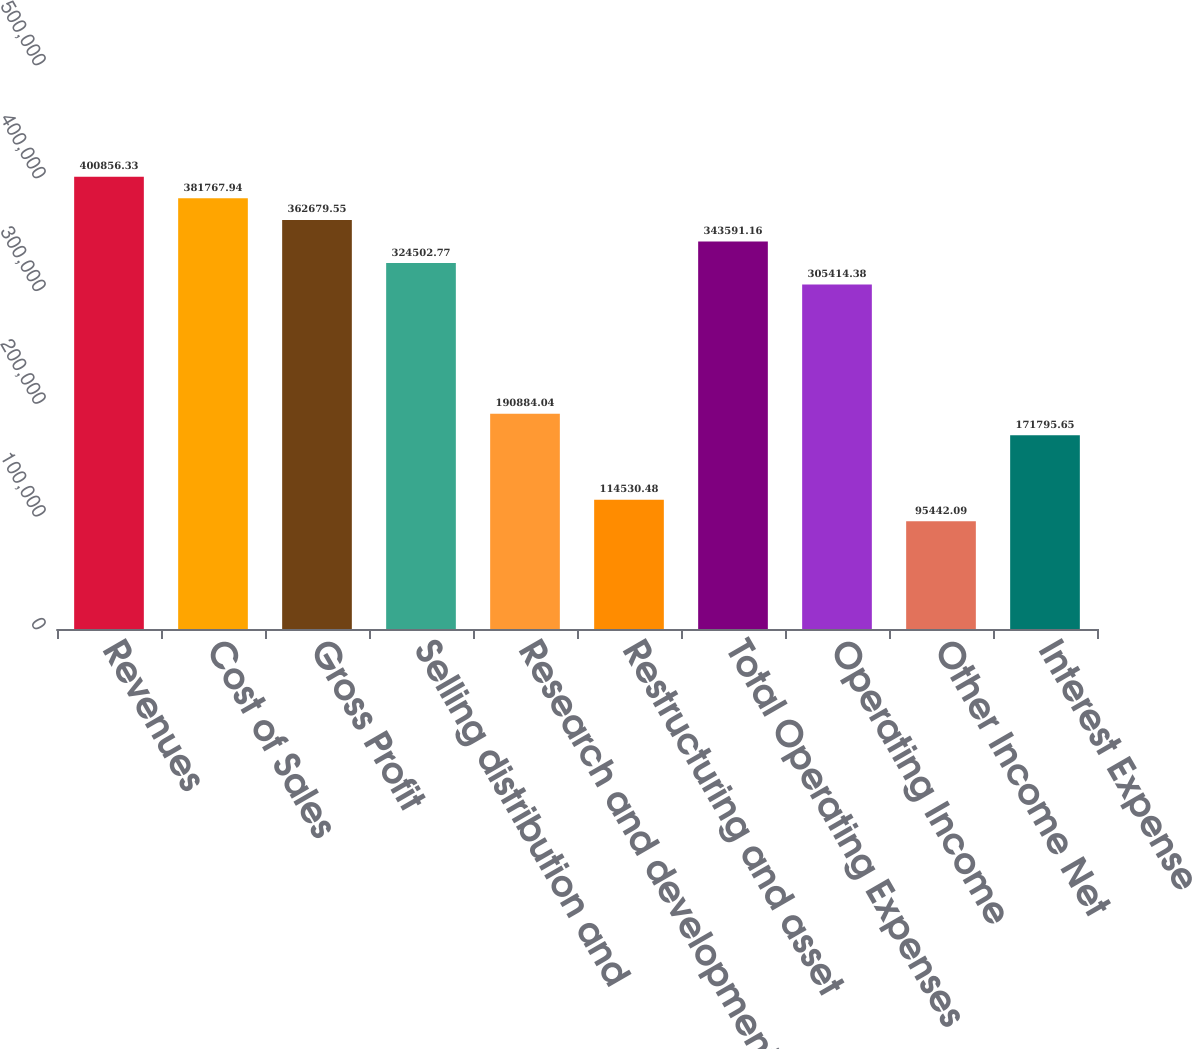Convert chart. <chart><loc_0><loc_0><loc_500><loc_500><bar_chart><fcel>Revenues<fcel>Cost of Sales<fcel>Gross Profit<fcel>Selling distribution and<fcel>Research and development<fcel>Restructuring and asset<fcel>Total Operating Expenses<fcel>Operating Income<fcel>Other Income Net<fcel>Interest Expense<nl><fcel>400856<fcel>381768<fcel>362680<fcel>324503<fcel>190884<fcel>114530<fcel>343591<fcel>305414<fcel>95442.1<fcel>171796<nl></chart> 